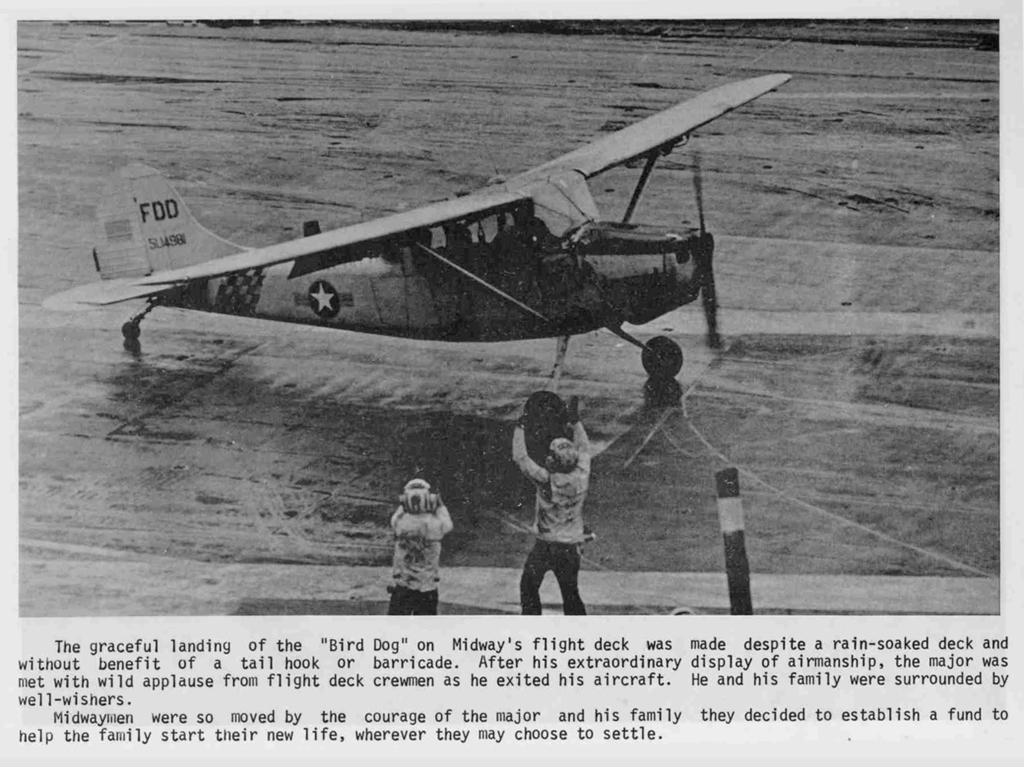Please provide a concise description of this image. In this image I can see a aircraft and two people and something is written on it. The image is in black and white. 